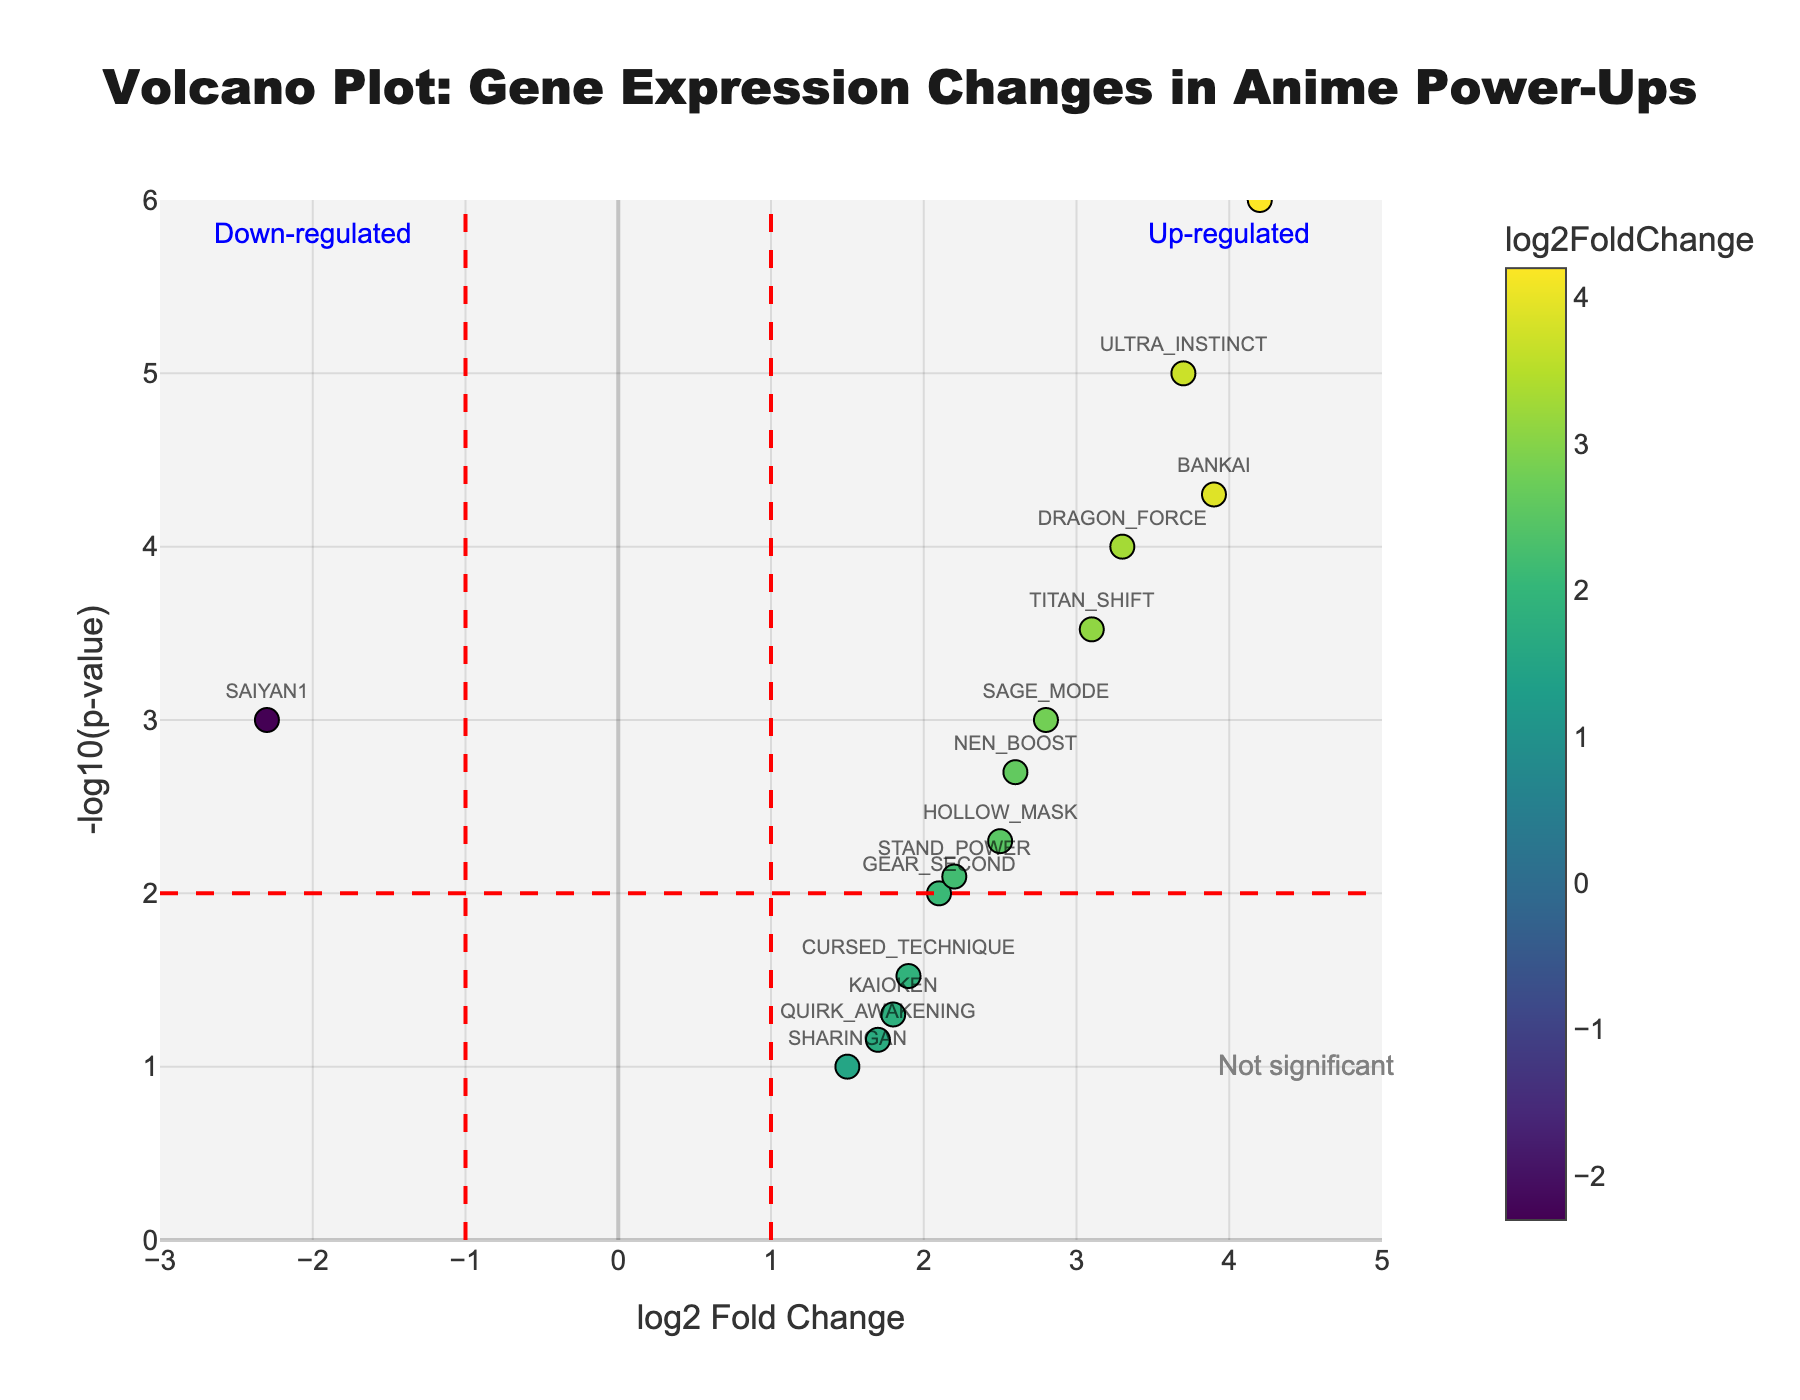What is the title of the figure? The title is generally placed at the top of the figure, and in this case, it is also specified in the data. The title is "Volcano Plot: Gene Expression Changes in Anime Power-Ups".
Answer: Volcano Plot: Gene Expression Changes in Anime Power-Ups How many genes are plotted in the figure? The figure plots data for each gene as a point, and each point is labeled with the gene's name. Counting these points will give the number of genes.
Answer: 15 Which gene has the highest log2 Fold Change? By looking at the x-axis (log2 Fold Change) values, we can see which gene is furthest to the right. The gene with the highest log2 Fold Change is "SUPER_SAIYAN" at 4.2.
Answer: SUPER_SAIYAN Which gene has the lowest p-value? The lowest p-value corresponds to the highest -log10(p-value), which can be found by looking at the y-axis values. "SUPER_SAIYAN" has the lowest p-value (highest -log10(p-value)).
Answer: SUPER_SAIYAN How many genes are considered up-regulated based on the threshold lines in the plot? Up-regulated genes are found to the right of the vertical red line at log2 Fold Change = 1, and above the horizontal red line at -log10(p-value) = 2. We can count these points visually.
Answer: 9 How many genes are considered down-regulated based on the threshold lines in the plot? Down-regulated genes are to the left of the vertical red line at log2 Fold Change = -1, and above the horizontal red line at -log10(p-value) = 2. We can count these points visually.
Answer: 1 Which gene has a log2 Fold Change closest to zero? The gene closest to the vertical axis (log2 Fold Change = 0) is the one with the smallest absolute log2 Fold Change. "SHARINGAN" has a log2 Fold Change closest to zero at 1.5.
Answer: SHARINGAN What is the -log10(p-value) for "BANKAI"? The y-axis represents the -log10(p-value), and we can refer to the hover information or plot label to find the value for "BANKAI". It is 4.3.
Answer: 4.3 Which two genes have log2 Fold Changes approximately within 0.1 of each other? By comparing the log2 Fold Change values and finding pairs with a difference of around 0.1, we can determine that "CURSED_TECHNIQUE" (1.9) and "GEAR_SECOND" (2.1) are within 0.1 of each other.
Answer: CURSED_TECHNIQUE and GEAR_SECOND What does the horizontal red line at -log10(p-value) = 2 signify in the context of the plot? Horizontal red lines generally denote significance thresholds for p-values. The line at -log10(p-value) = 2 represents a significance cutoff. Any gene above this line is considered statistically significant (p-value < 0.01).
Answer: Significance threshold 